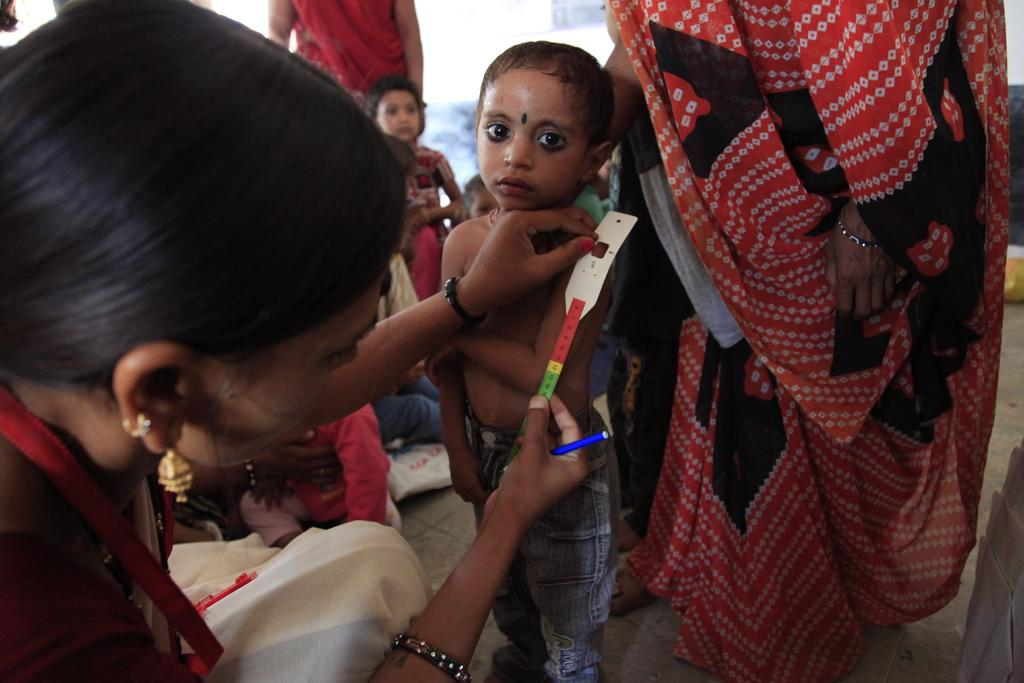How many people are in the image? There are people in the image, but the exact number is not specified. What is the person wearing an ID card holding? The person with the ID card is holding a scale and a pen. What is the purpose of the scale? The purpose of the scale is not specified, but it is likely used for weighing objects. What is the surface on which the people are standing? There is a floor at the bottom of the image. What type of bells can be heard ringing in the image? There are no bells present in the image, and therefore no sound can be heard. 